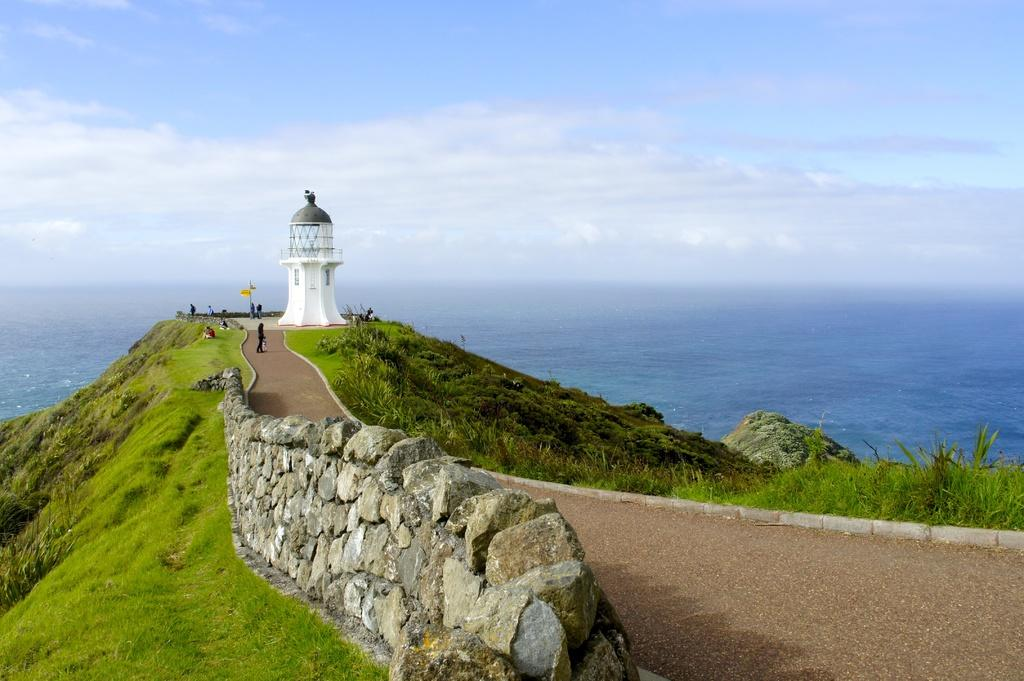What is the main structure in the center of the image? There is a tower in the center of the image. Can you describe the people visible in the image? There are people visible in the image, but their specific actions or characteristics are not mentioned in the facts. What type of barrier is at the bottom of the image? There is: There is a stone wall at the bottom of the image. What type of vegetation can be seen in the image? There is grass visible in the image. What can be seen in the background of the image? In the background of the image, there is a hill, water, and the sky. What type of vegetable is being prepared by the maid in the image? There is no maid or vegetable present in the image. 